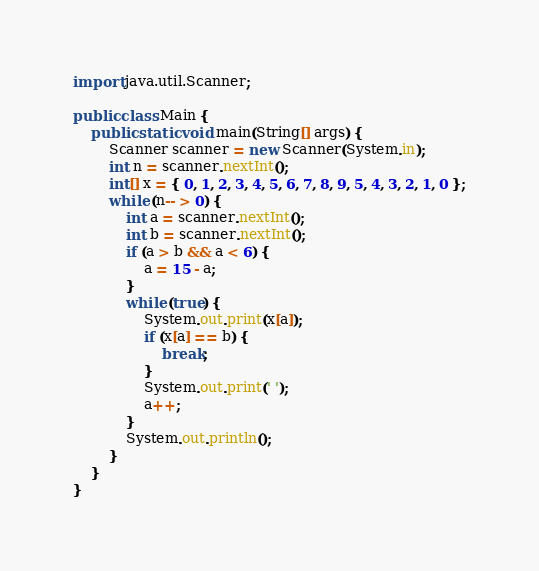Convert code to text. <code><loc_0><loc_0><loc_500><loc_500><_Java_>
import java.util.Scanner;

public class Main {
	public static void main(String[] args) {
		Scanner scanner = new Scanner(System.in);
		int n = scanner.nextInt();
		int[] x = { 0, 1, 2, 3, 4, 5, 6, 7, 8, 9, 5, 4, 3, 2, 1, 0 };
		while (n-- > 0) {
			int a = scanner.nextInt();
			int b = scanner.nextInt();
			if (a > b && a < 6) {
				a = 15 - a;
			}
			while (true) {
				System.out.print(x[a]);
				if (x[a] == b) {
					break;
				}
				System.out.print(' ');
				a++;
			}
			System.out.println();
		}
	}
}</code> 